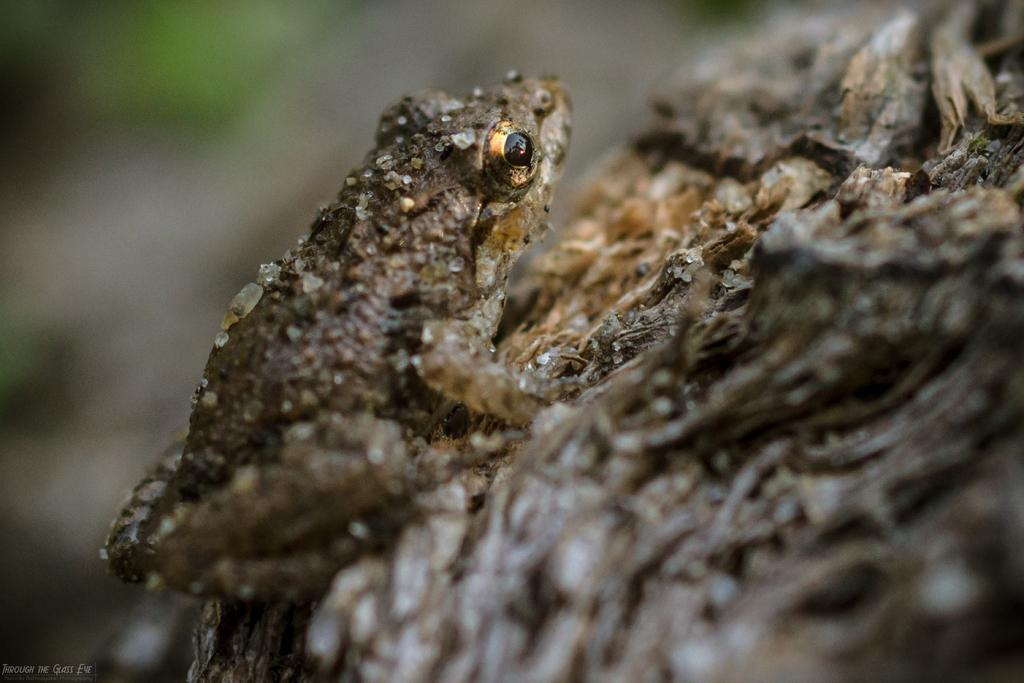What type of animal is in the image? There is a frog in the image. What color is the frog? The frog is brown in color. What is the frog sitting on? The frog is on a brown surface. How would you describe the background of the image? The background of the image is blurred. What time does the frog sneeze in the image? Frogs do not sneeze, and there is no indication of time in the image. 